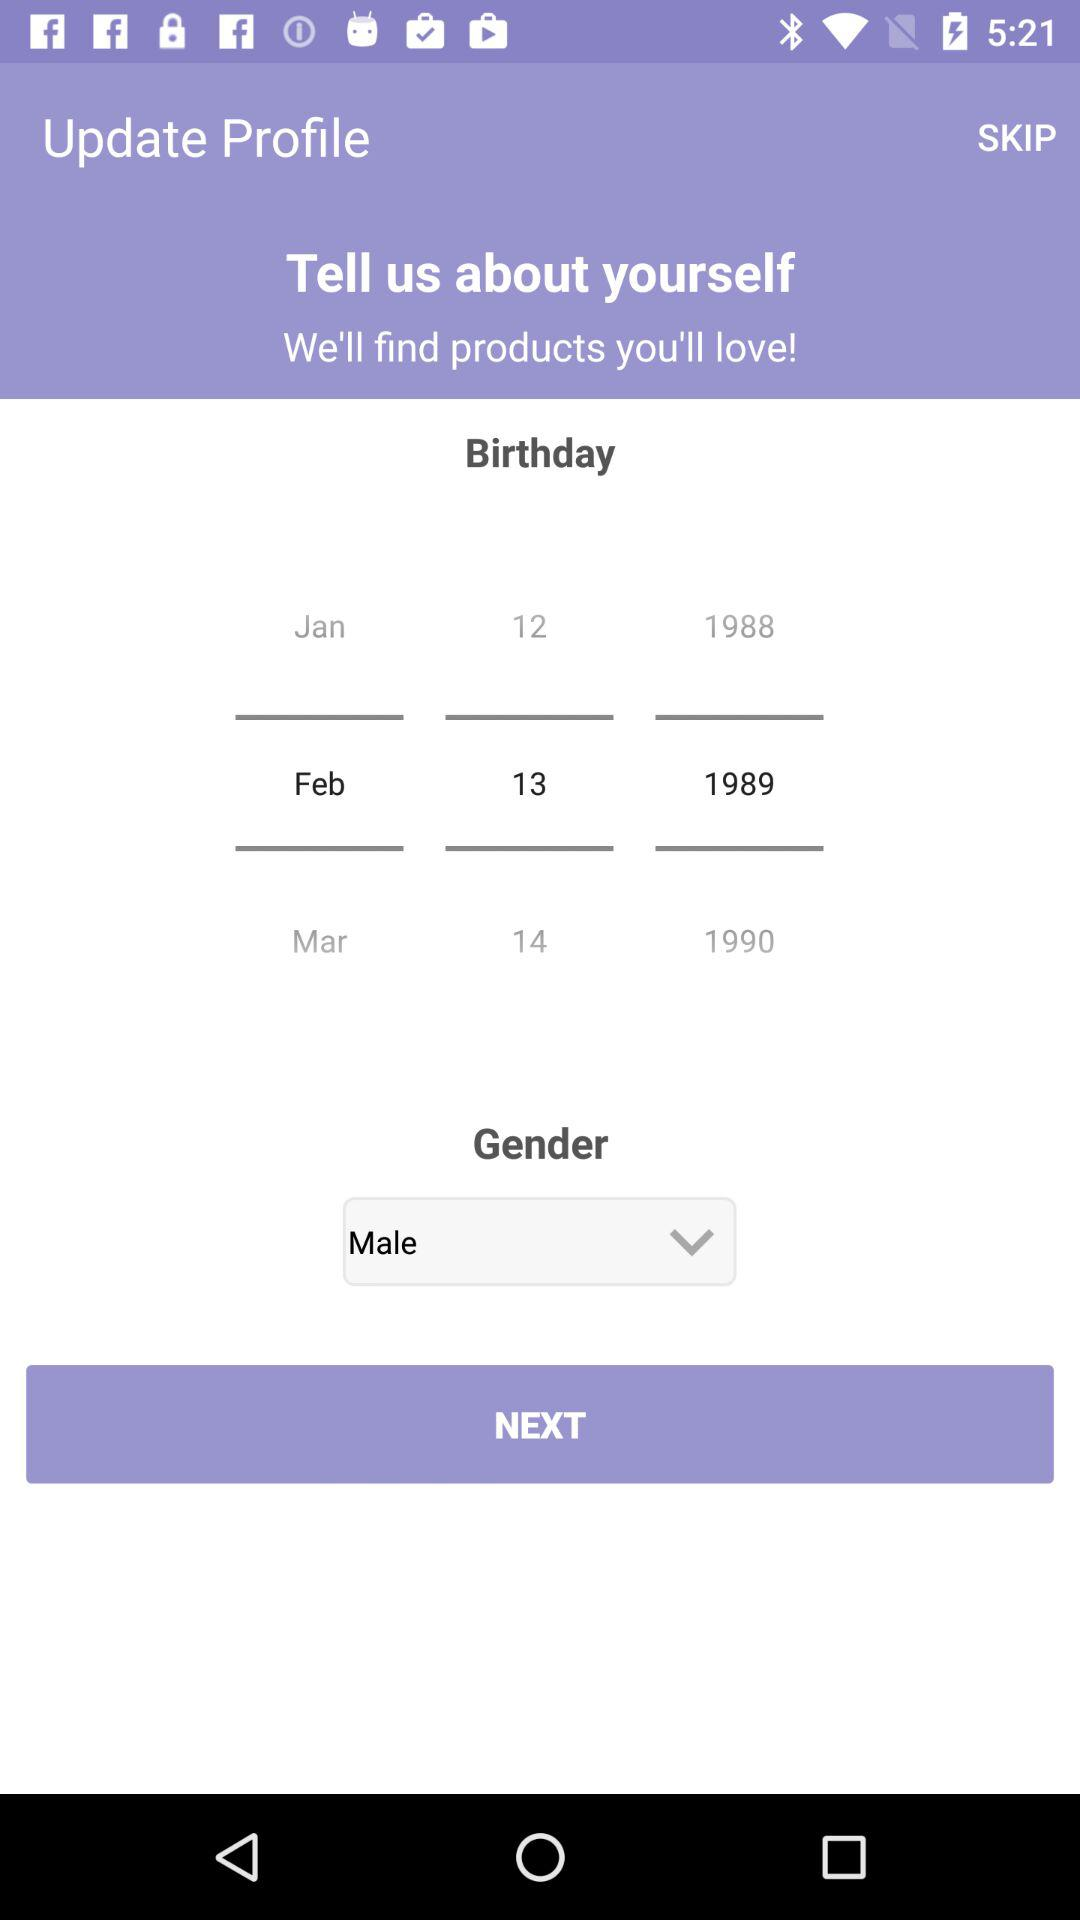How many more years are there between 1988 and 1990?
Answer the question using a single word or phrase. 2 